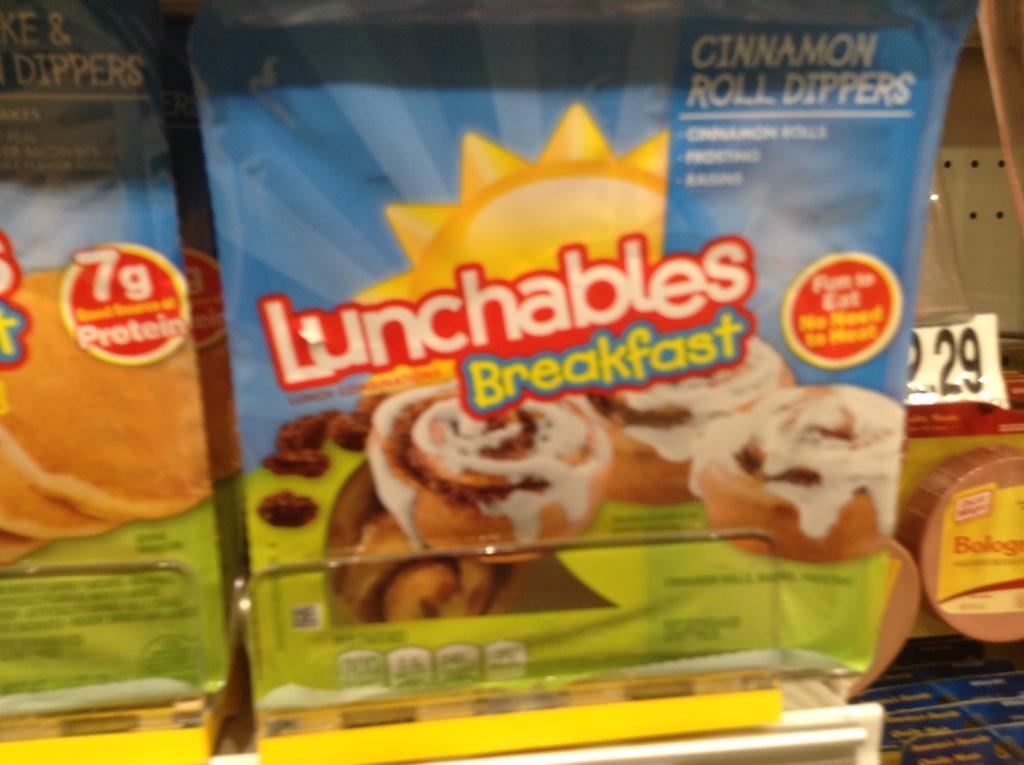Could you give a brief overview of what you see in this image? In this image we can see group of food packages placed on the rack. In the background ,we can see numbers on a paper. 